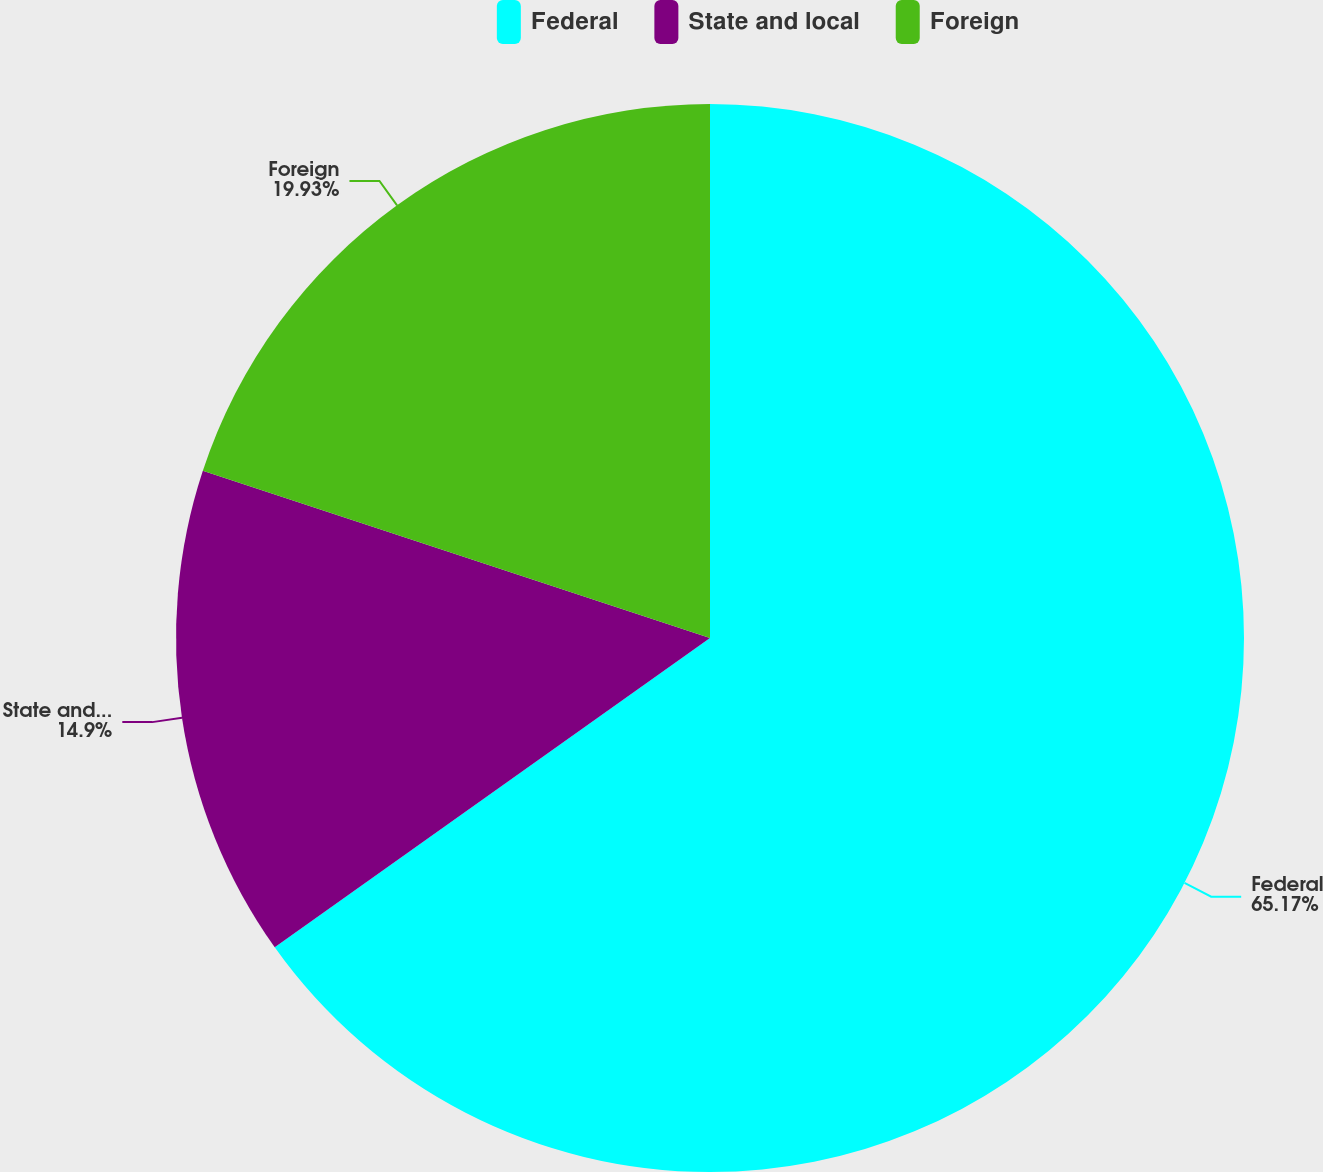Convert chart. <chart><loc_0><loc_0><loc_500><loc_500><pie_chart><fcel>Federal<fcel>State and local<fcel>Foreign<nl><fcel>65.16%<fcel>14.9%<fcel>19.93%<nl></chart> 